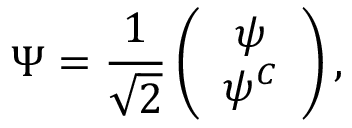<formula> <loc_0><loc_0><loc_500><loc_500>\Psi = \frac { 1 } { \sqrt { 2 } } \left ( \begin{array} { c } { \psi } \\ { { \psi ^ { C } } } \end{array} \right ) ,</formula> 